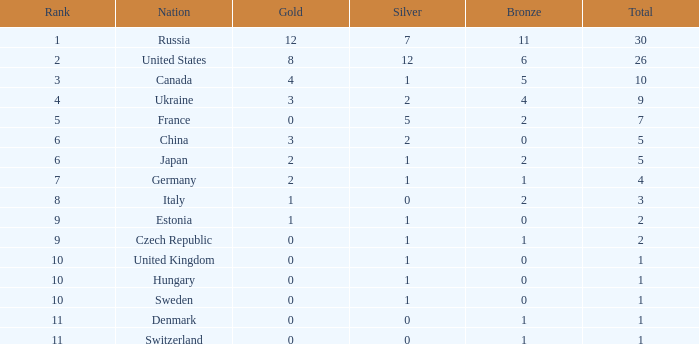How many silvers have a Nation of hungary, and a Rank larger than 10? 0.0. 